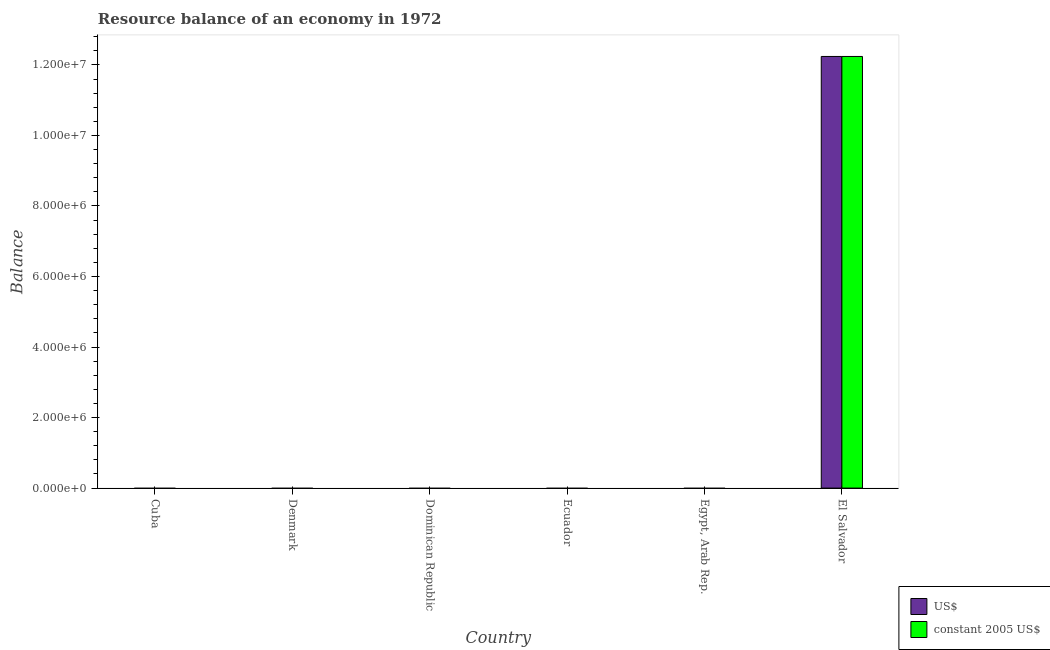How many different coloured bars are there?
Provide a short and direct response. 2. Are the number of bars per tick equal to the number of legend labels?
Keep it short and to the point. No. Are the number of bars on each tick of the X-axis equal?
Provide a succinct answer. No. How many bars are there on the 6th tick from the left?
Offer a terse response. 2. How many bars are there on the 2nd tick from the right?
Offer a terse response. 0. What is the label of the 4th group of bars from the left?
Your response must be concise. Ecuador. Across all countries, what is the maximum resource balance in constant us$?
Ensure brevity in your answer.  1.22e+07. Across all countries, what is the minimum resource balance in us$?
Provide a short and direct response. 0. In which country was the resource balance in constant us$ maximum?
Keep it short and to the point. El Salvador. What is the total resource balance in us$ in the graph?
Your answer should be compact. 1.22e+07. What is the difference between the resource balance in constant us$ in El Salvador and the resource balance in us$ in Dominican Republic?
Make the answer very short. 1.22e+07. What is the average resource balance in us$ per country?
Offer a terse response. 2.04e+06. What is the difference between the highest and the lowest resource balance in constant us$?
Offer a very short reply. 1.22e+07. Are the values on the major ticks of Y-axis written in scientific E-notation?
Offer a very short reply. Yes. Does the graph contain any zero values?
Provide a succinct answer. Yes. Where does the legend appear in the graph?
Provide a succinct answer. Bottom right. How are the legend labels stacked?
Give a very brief answer. Vertical. What is the title of the graph?
Make the answer very short. Resource balance of an economy in 1972. What is the label or title of the X-axis?
Provide a succinct answer. Country. What is the label or title of the Y-axis?
Give a very brief answer. Balance. What is the Balance of US$ in Denmark?
Keep it short and to the point. 0. What is the Balance in constant 2005 US$ in Denmark?
Keep it short and to the point. 0. What is the Balance of US$ in Dominican Republic?
Give a very brief answer. 0. What is the Balance in constant 2005 US$ in Dominican Republic?
Offer a very short reply. 0. What is the Balance of constant 2005 US$ in Ecuador?
Your answer should be very brief. 0. What is the Balance of US$ in El Salvador?
Ensure brevity in your answer.  1.22e+07. What is the Balance in constant 2005 US$ in El Salvador?
Ensure brevity in your answer.  1.22e+07. Across all countries, what is the maximum Balance of US$?
Provide a short and direct response. 1.22e+07. Across all countries, what is the maximum Balance of constant 2005 US$?
Your answer should be very brief. 1.22e+07. Across all countries, what is the minimum Balance in US$?
Provide a short and direct response. 0. What is the total Balance of US$ in the graph?
Make the answer very short. 1.22e+07. What is the total Balance in constant 2005 US$ in the graph?
Ensure brevity in your answer.  1.22e+07. What is the average Balance in US$ per country?
Keep it short and to the point. 2.04e+06. What is the average Balance in constant 2005 US$ per country?
Keep it short and to the point. 2.04e+06. What is the difference between the highest and the lowest Balance of US$?
Your response must be concise. 1.22e+07. What is the difference between the highest and the lowest Balance in constant 2005 US$?
Make the answer very short. 1.22e+07. 